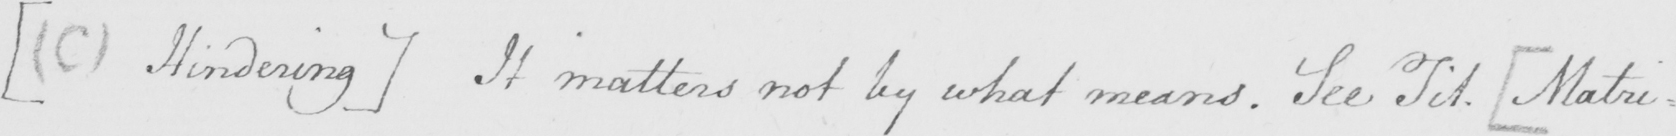What text is written in this handwritten line? [  ( C )  Hindering ]  It matters not by what means . See Tit .  [ Matri= 